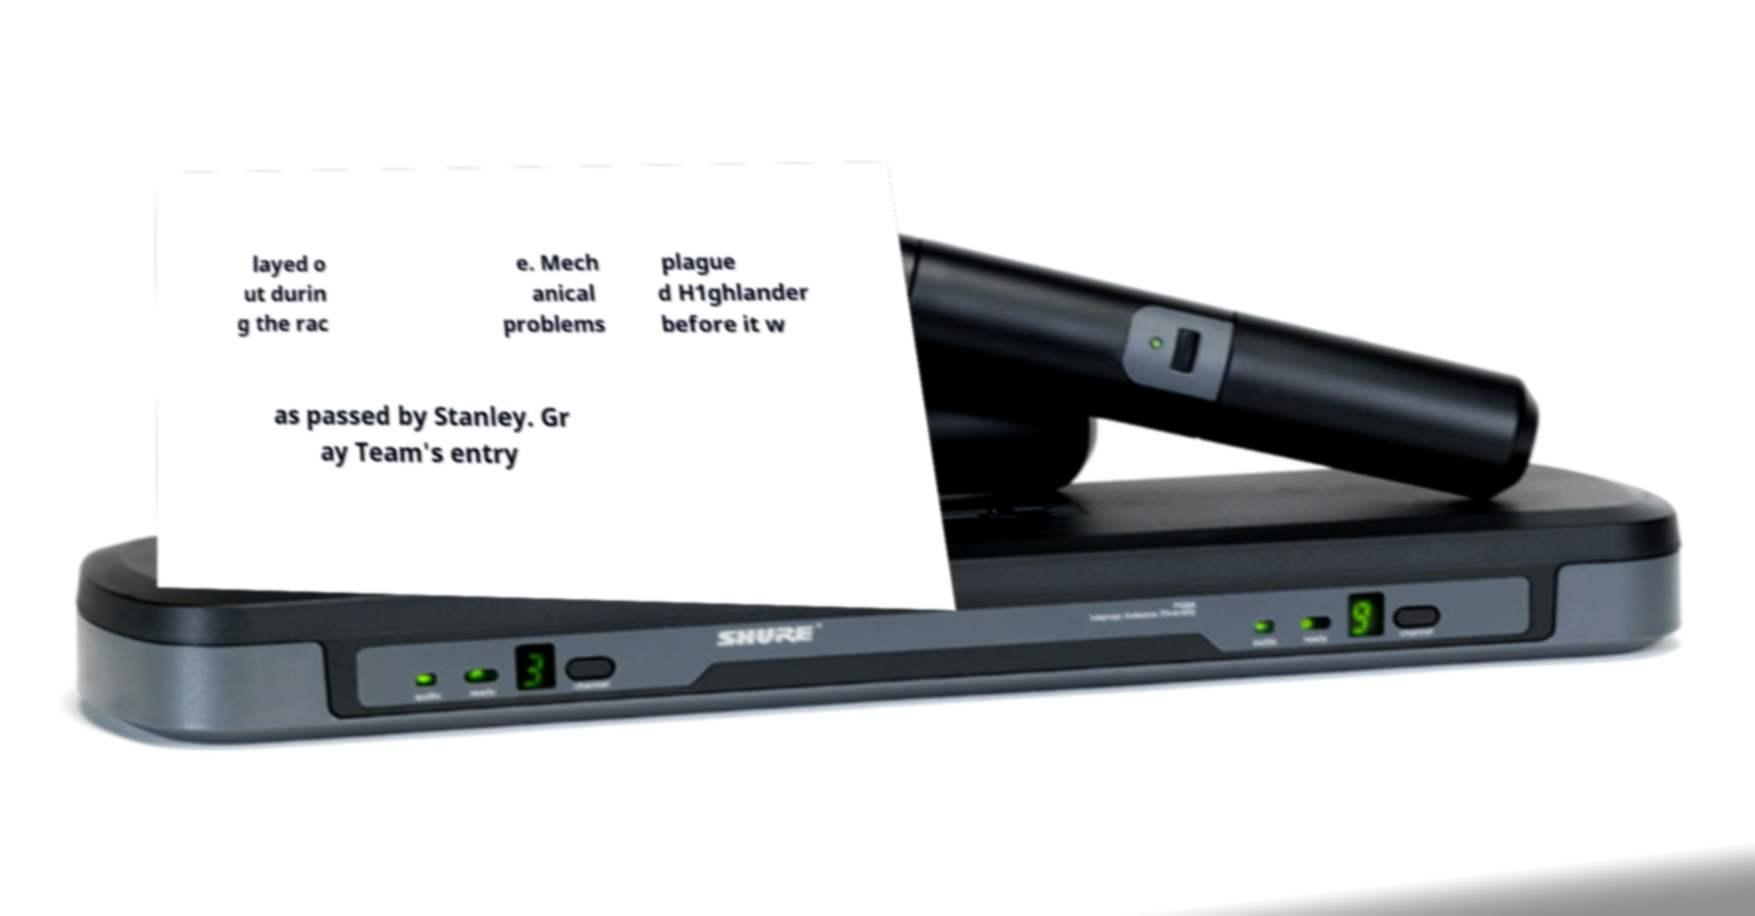Can you read and provide the text displayed in the image?This photo seems to have some interesting text. Can you extract and type it out for me? layed o ut durin g the rac e. Mech anical problems plague d H1ghlander before it w as passed by Stanley. Gr ay Team's entry 